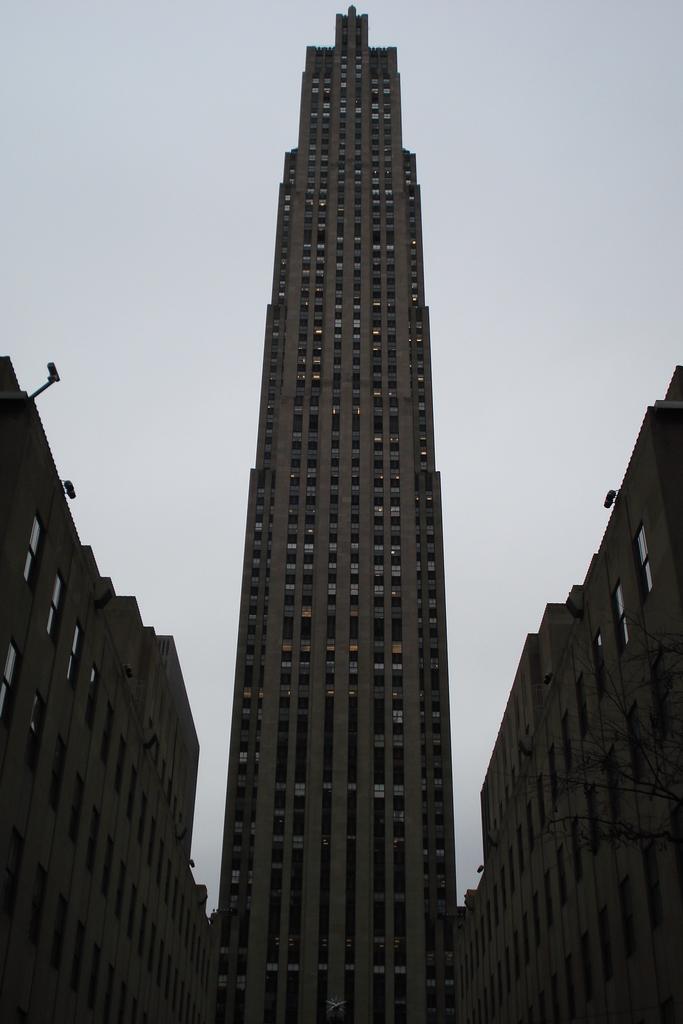Can you describe this image briefly? These are buildings with windows. 